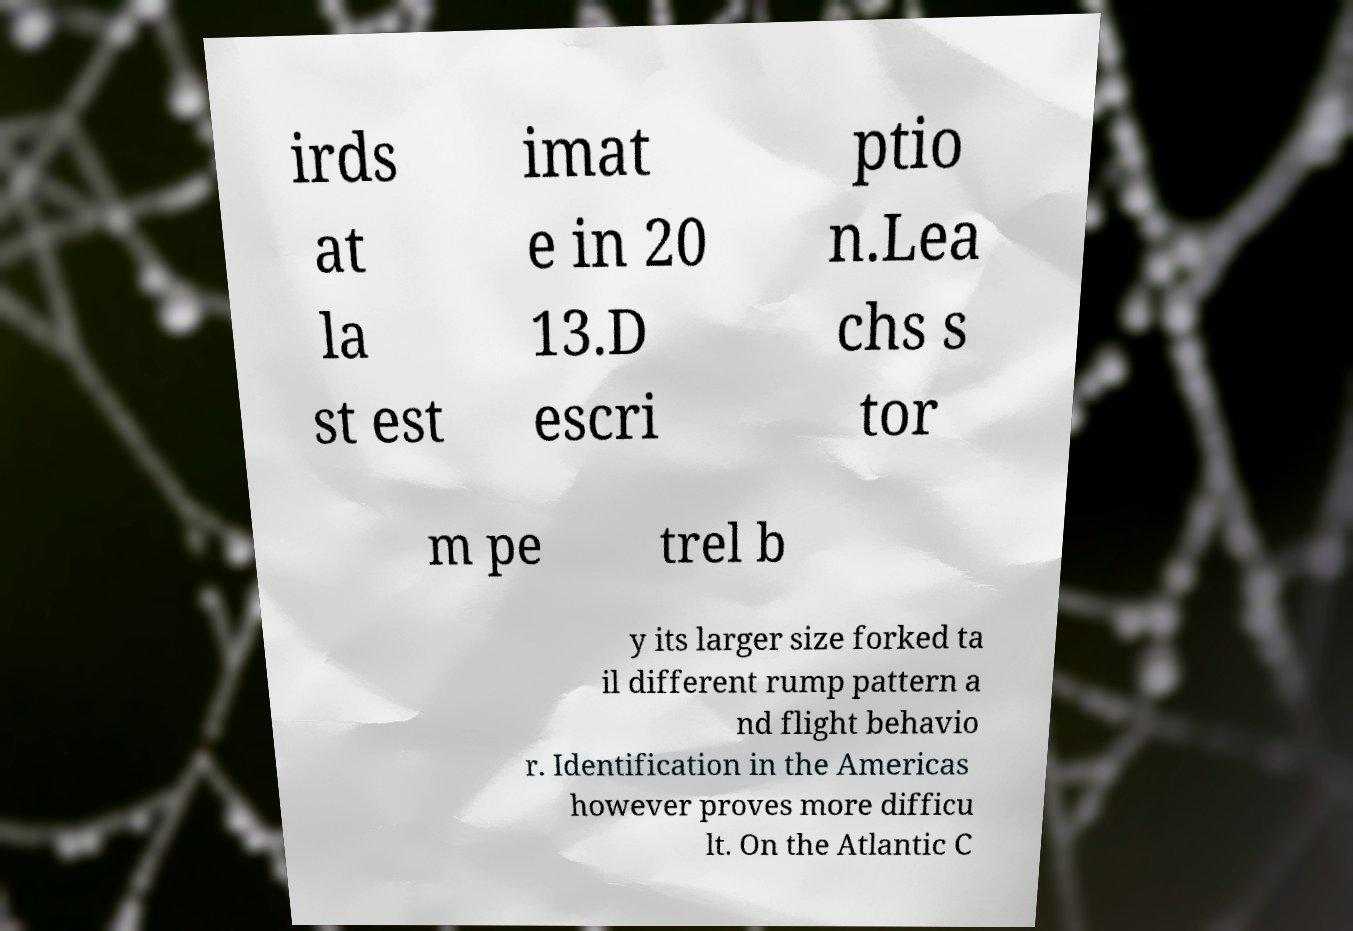What messages or text are displayed in this image? I need them in a readable, typed format. irds at la st est imat e in 20 13.D escri ptio n.Lea chs s tor m pe trel b y its larger size forked ta il different rump pattern a nd flight behavio r. Identification in the Americas however proves more difficu lt. On the Atlantic C 